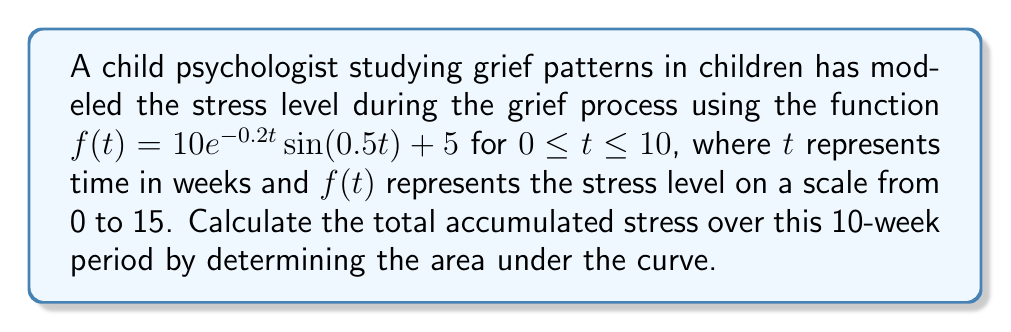Provide a solution to this math problem. To find the area under the curve, we need to integrate the function $f(t)$ from 0 to 10:

$$\int_0^{10} (10e^{-0.2t}\sin(0.5t) + 5) dt$$

Let's break this down into two parts:

1) $\int_0^{10} 5 dt = 5t \Big|_0^{10} = 50$

2) For $\int_0^{10} 10e^{-0.2t}\sin(0.5t) dt$, we need to use integration by parts.

Let $u = \sin(0.5t)$ and $dv = 10e^{-0.2t}dt$

Then $du = 0.5\cos(0.5t)dt$ and $v = -50e^{-0.2t}$

$$\int 10e^{-0.2t}\sin(0.5t) dt = -50e^{-0.2t}\sin(0.5t) - \int -50e^{-0.2t} \cdot 0.5\cos(0.5t)dt$$

$$= -50e^{-0.2t}\sin(0.5t) + 25\int e^{-0.2t}\cos(0.5t)dt$$

We need to integrate by parts again for the second term. Let's call this integral $I$.

$$I = -50e^{-0.2t}\sin(0.5t) - 25e^{-0.2t}\cos(0.5t) - 5I$$

Solving for $I$:

$$6I = -50e^{-0.2t}\sin(0.5t) - 25e^{-0.2t}\cos(0.5t)$$

$$I = -\frac{25}{3}e^{-0.2t}(\sin(0.5t) + 0.5\cos(0.5t))$$

Now, we need to evaluate this from 0 to 10:

$$\left[-\frac{25}{3}e^{-0.2t}(\sin(0.5t) + 0.5\cos(0.5t))\right]_0^{10} + 50$$

$$= -\frac{25}{3}e^{-2}(\sin(5) + 0.5\cos(5)) + \frac{25}{6} + 50$$

$$\approx -1.40 + 4.17 + 50 = 52.77$$
Answer: 52.77 stress-weeks 